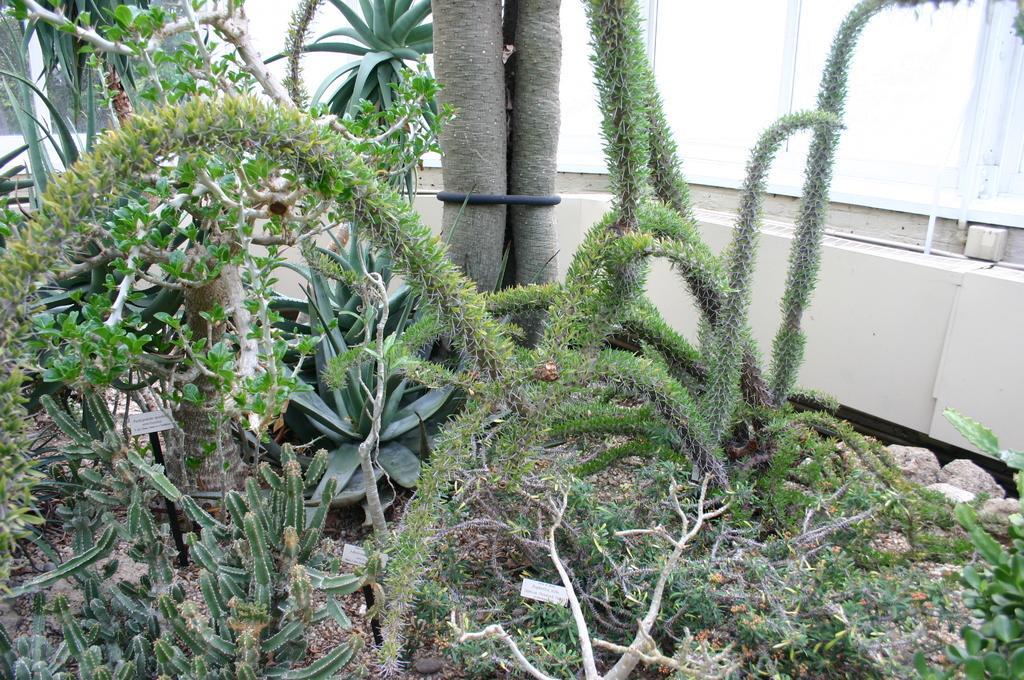How would you summarize this image in a sentence or two? This image in the front there are cactus plants. In the background there are plants and there is a wall which is cream in colour and there is a window. 